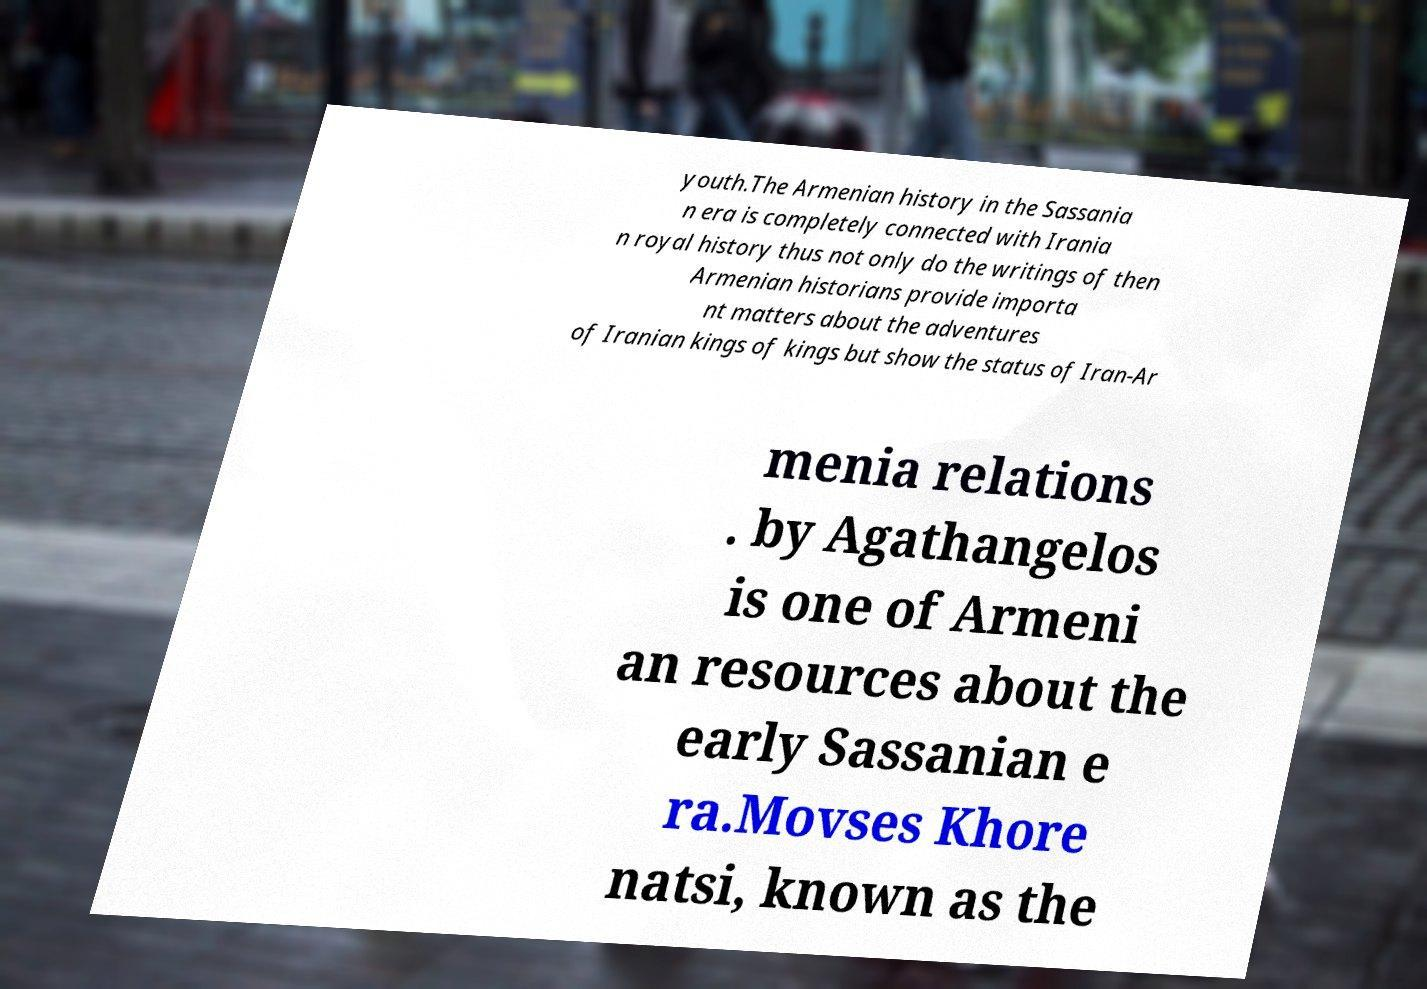Can you accurately transcribe the text from the provided image for me? youth.The Armenian history in the Sassania n era is completely connected with Irania n royal history thus not only do the writings of then Armenian historians provide importa nt matters about the adventures of Iranian kings of kings but show the status of Iran-Ar menia relations . by Agathangelos is one of Armeni an resources about the early Sassanian e ra.Movses Khore natsi, known as the 